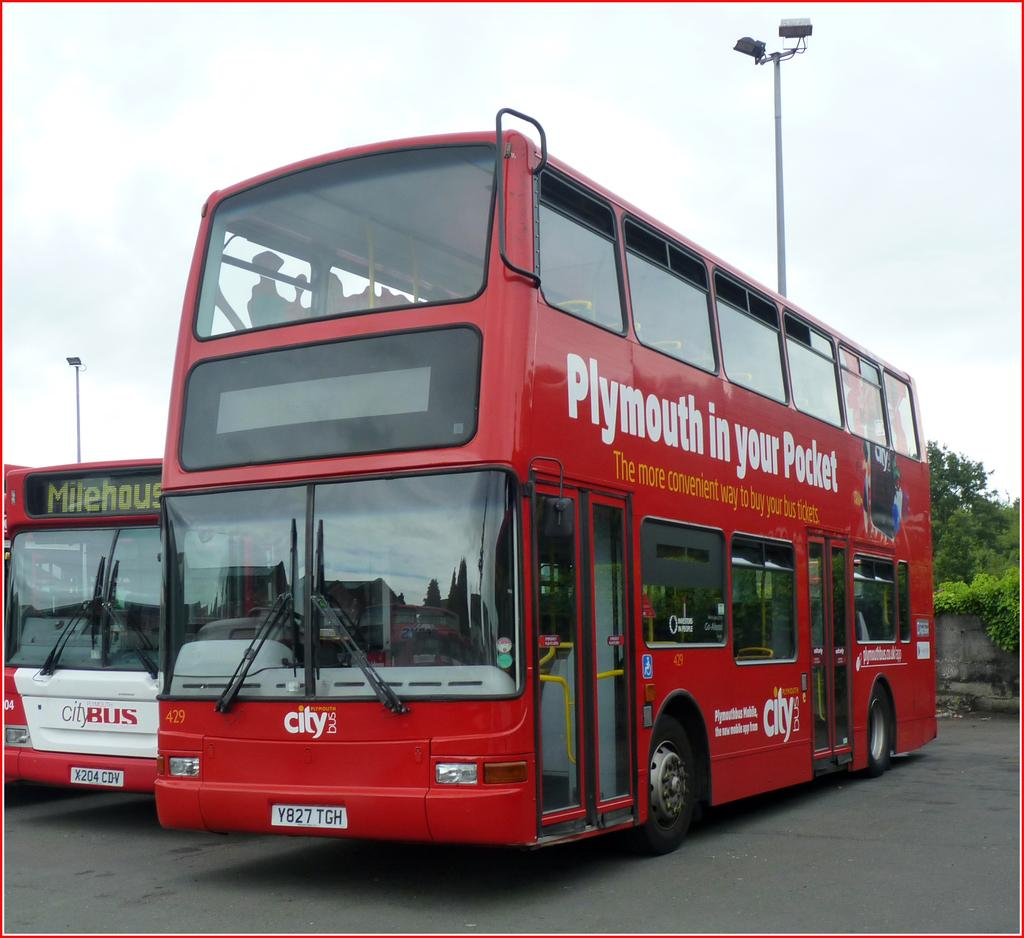<image>
Write a terse but informative summary of the picture. the word Plymouth is on the red bus 